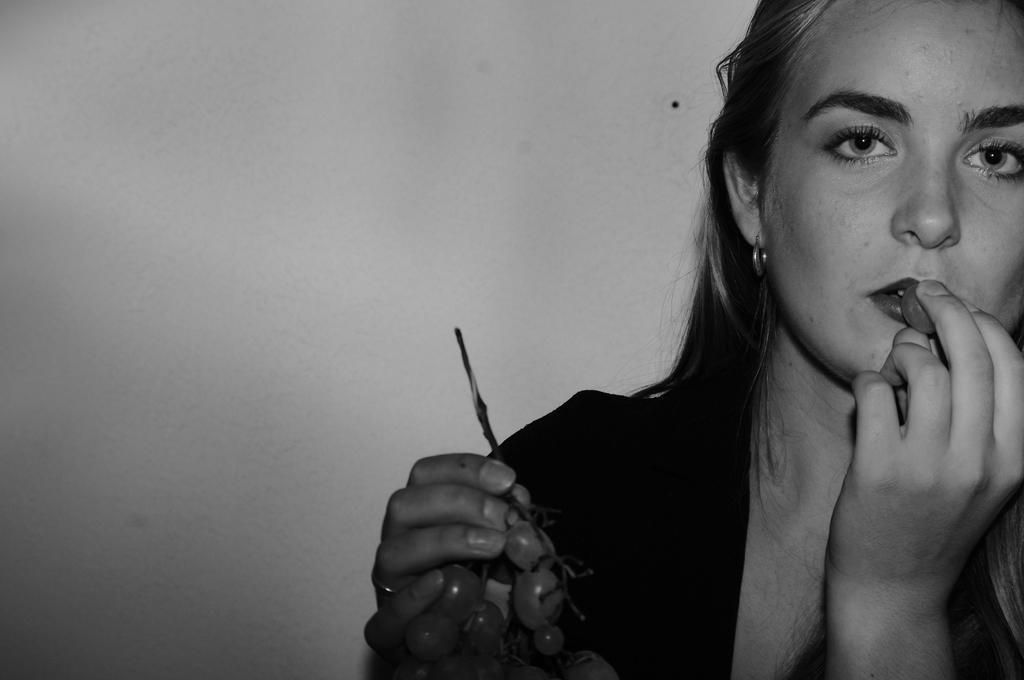Could you give a brief overview of what you see in this image? This picture is in black and white. Towards the right, there is a woman holding grapes. 